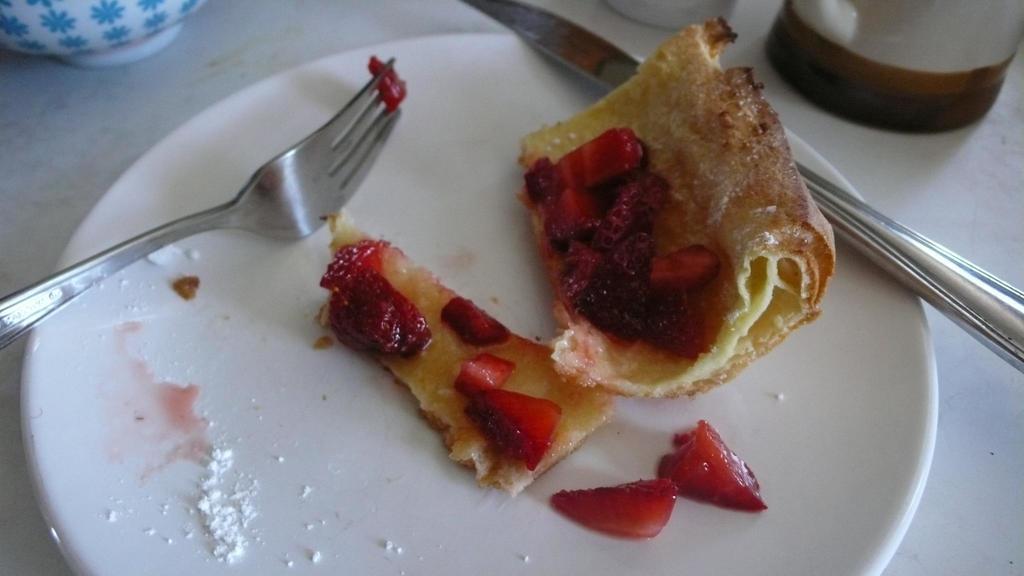Could you give a brief overview of what you see in this image? In the picture we can see a plate which is white in color with some fruit salads and bread on it with a fork and knife, and besides the plate we can see some bowl. 